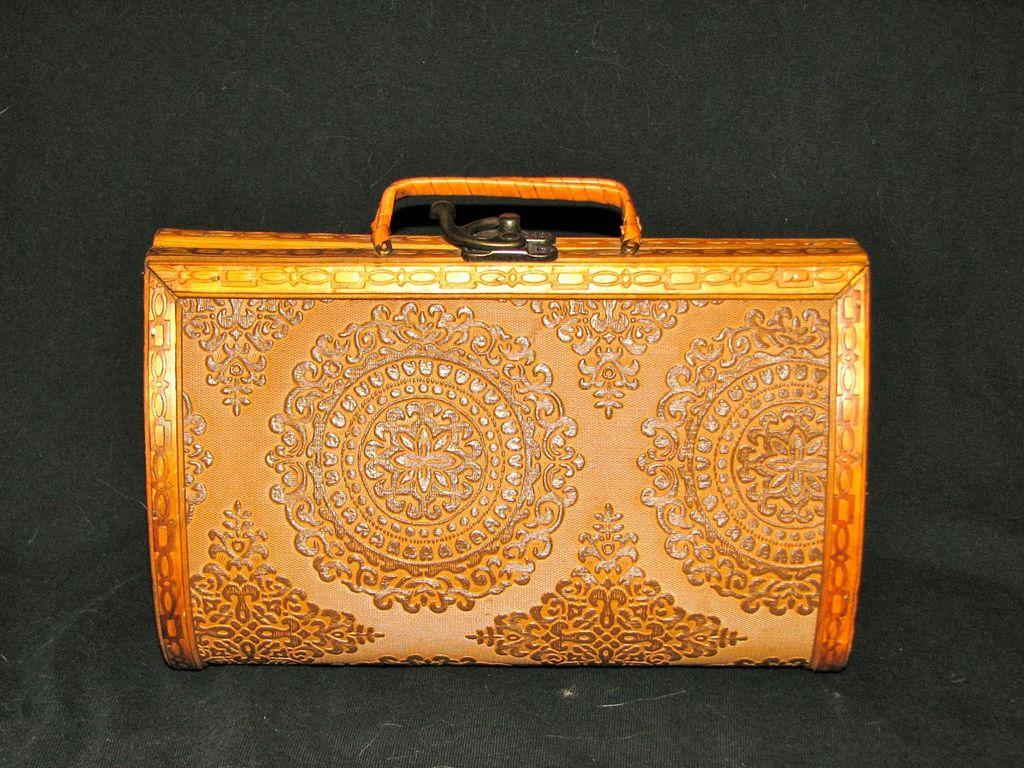What color is the bag in the image? The bag is orange in color. What feature does the bag have that is related to a specific location? The bag has a locker room. How many loaves of bread are visible in the image? There are no loaves of bread present in the image. What type of art is displayed on the bag in the image? There is no art displayed on the bag in the image. 